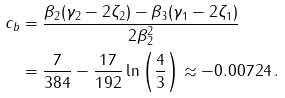Convert formula to latex. <formula><loc_0><loc_0><loc_500><loc_500>c _ { b } & = \frac { \beta _ { 2 } ( \gamma _ { 2 } - 2 \zeta _ { 2 } ) - \beta _ { 3 } ( \gamma _ { 1 } - 2 \zeta _ { 1 } ) } { 2 \beta _ { 2 } ^ { 2 } } \\ & = \frac { 7 } { 3 8 4 } - \frac { 1 7 } { 1 9 2 } \ln \left ( \frac { 4 } { 3 } \right ) \approx - 0 . 0 0 7 2 4 \, .</formula> 